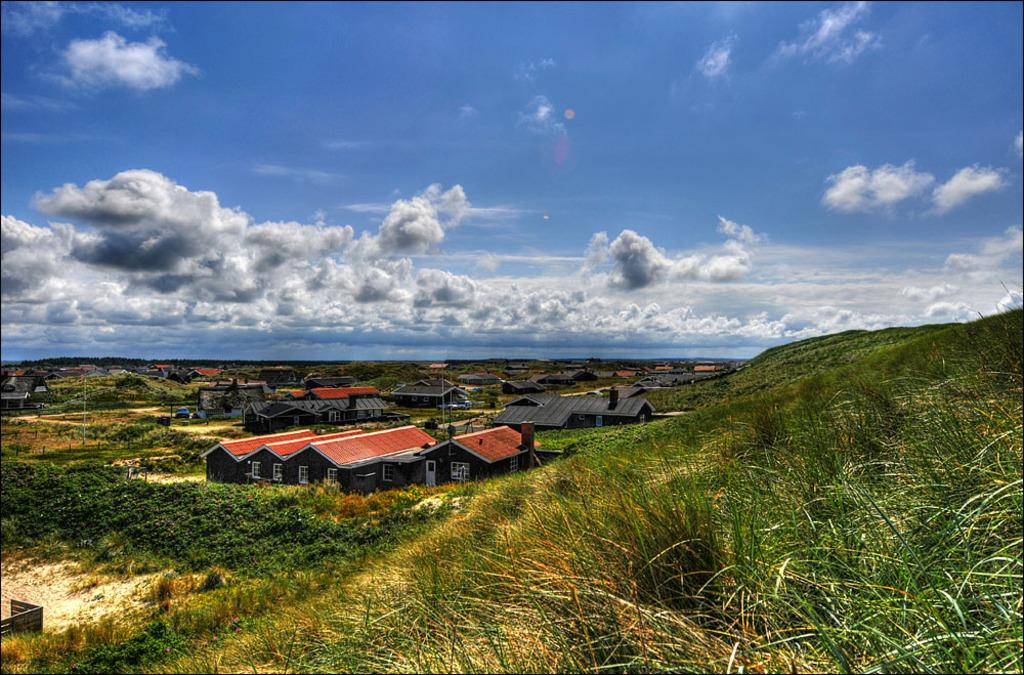What type of structures can be seen in the image? There are houses in the image. What type of vegetation is present in the image? There are trees, plants, and grass in the image. What is visible in the background of the image? The sky is visible in the background of the image. What type of snack is being shared among the houses in the image? There is no snack, such as popcorn, present in the image. The image features houses, trees, plants, grass, and the sky. 